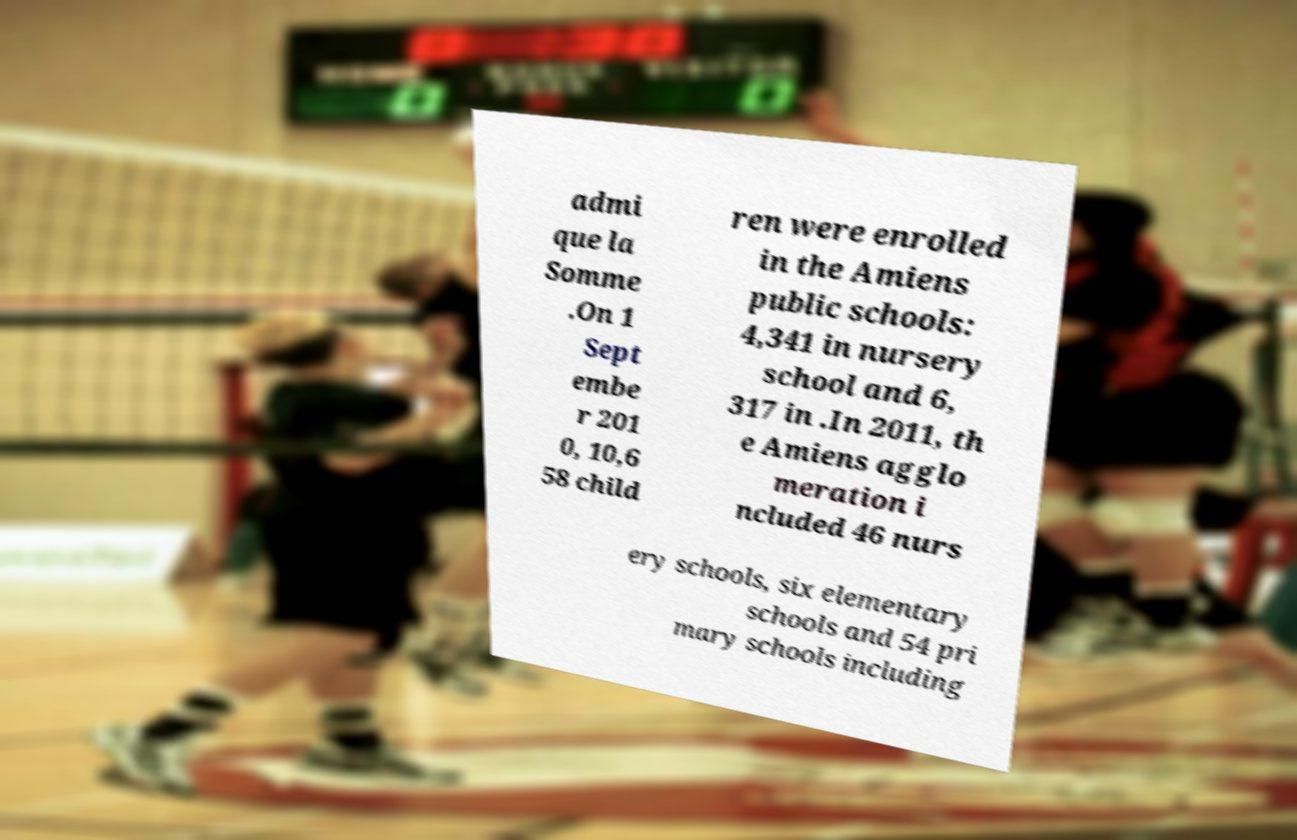What messages or text are displayed in this image? I need them in a readable, typed format. admi que la Somme .On 1 Sept embe r 201 0, 10,6 58 child ren were enrolled in the Amiens public schools: 4,341 in nursery school and 6, 317 in .In 2011, th e Amiens agglo meration i ncluded 46 nurs ery schools, six elementary schools and 54 pri mary schools including 